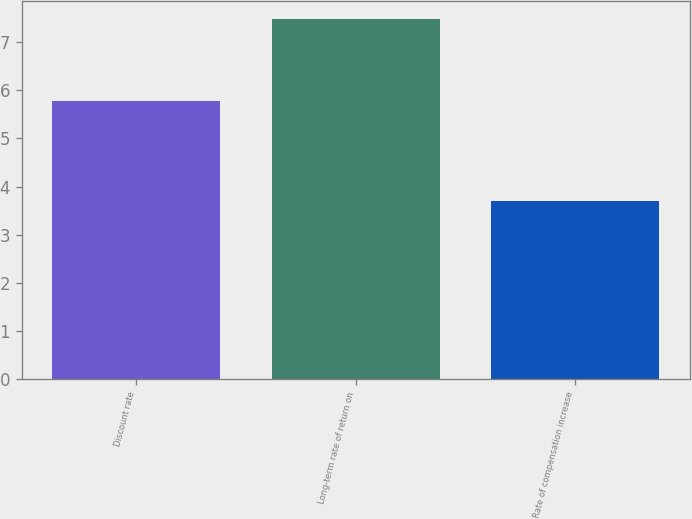Convert chart to OTSL. <chart><loc_0><loc_0><loc_500><loc_500><bar_chart><fcel>Discount rate<fcel>Long-term rate of return on<fcel>Rate of compensation increase<nl><fcel>5.78<fcel>7.48<fcel>3.7<nl></chart> 